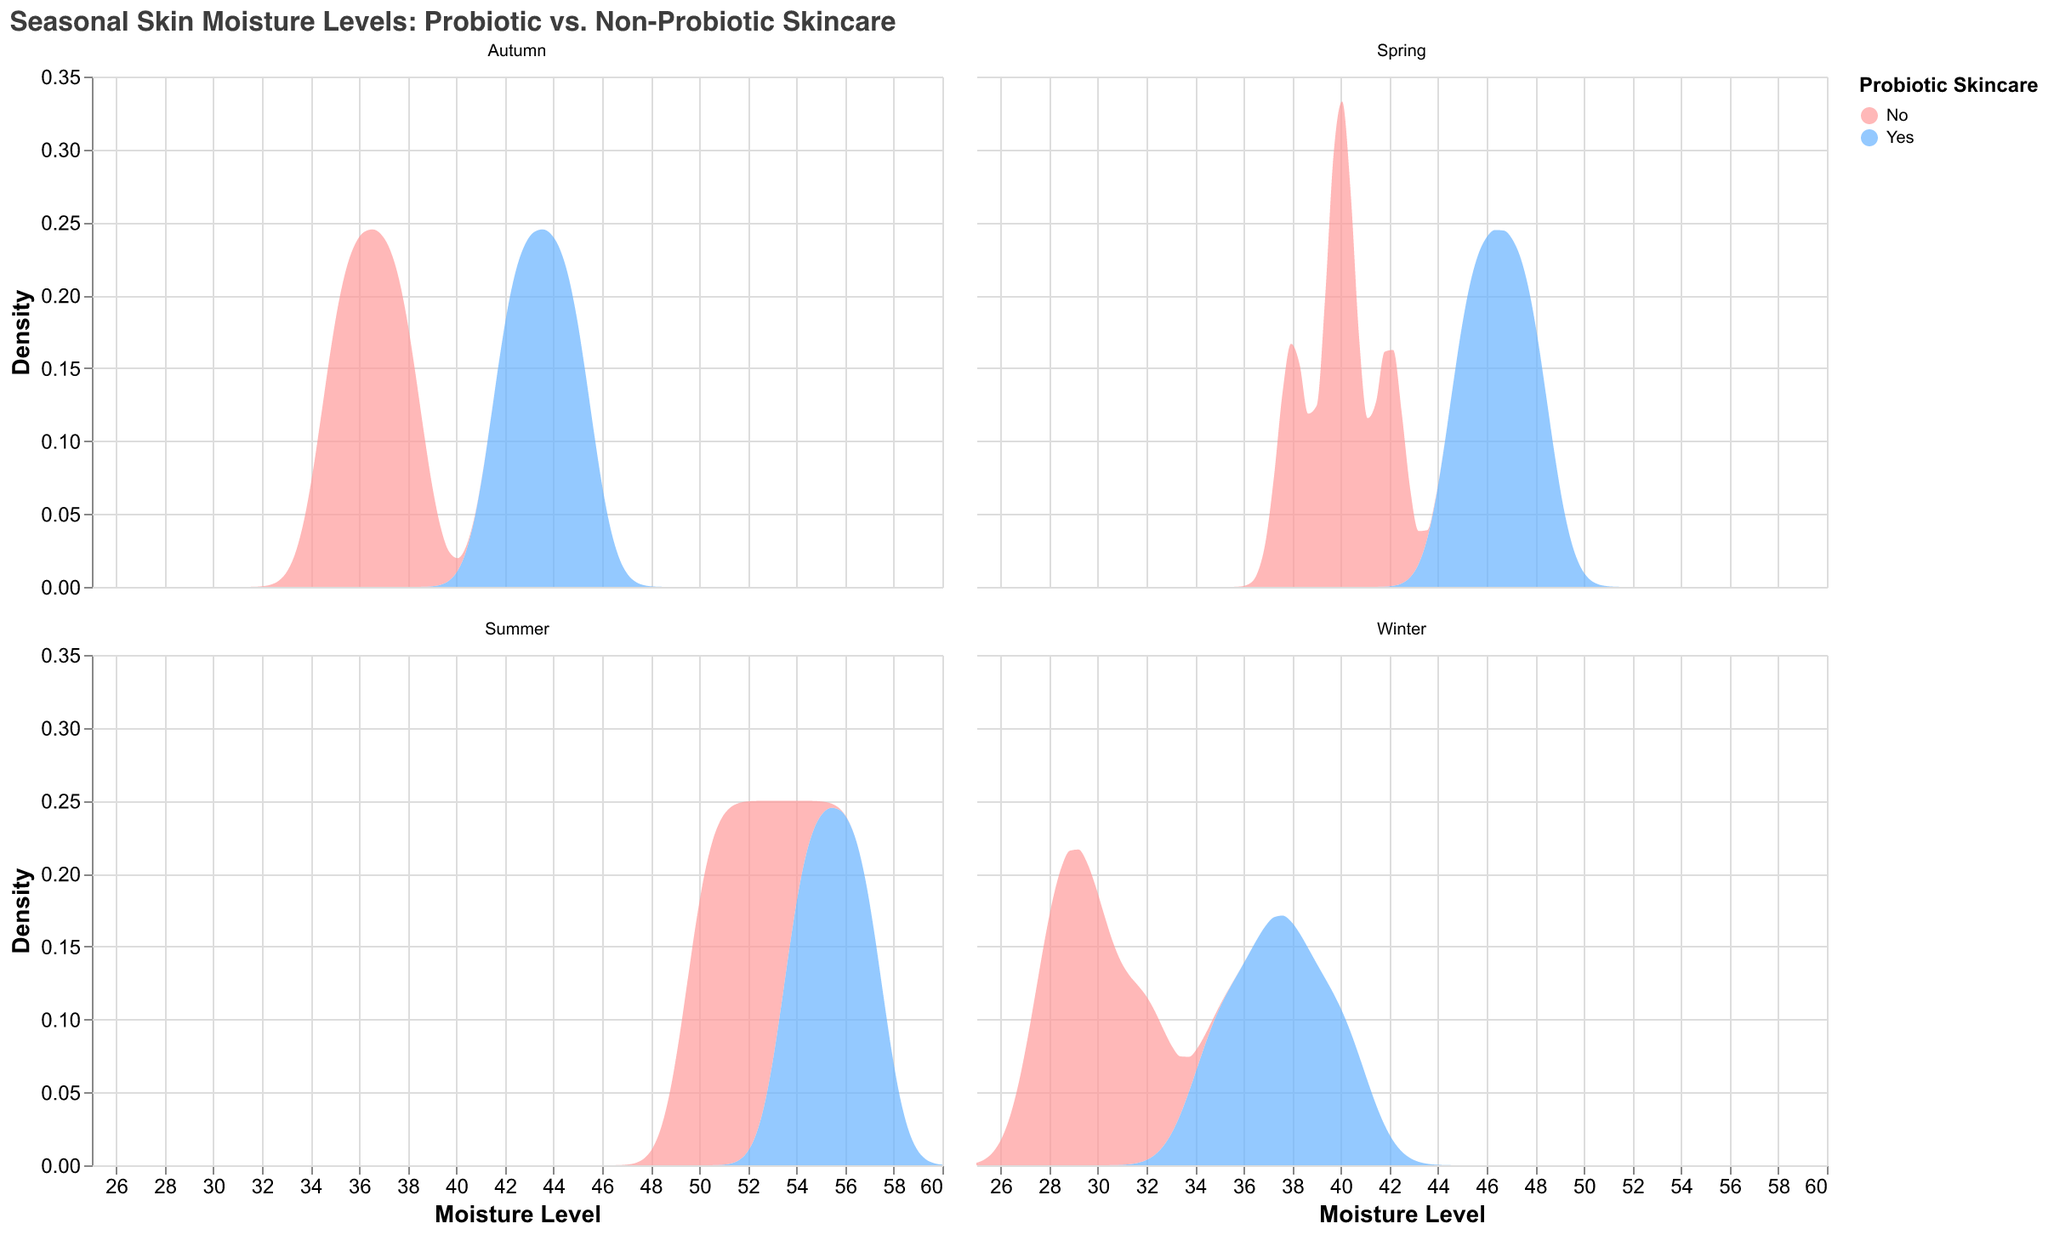What is the title of the plot? The title of the plot is displayed at the top of the figure. It reads "Seasonal Skin Moisture Levels: Probiotic vs. Non-Probiotic Skincare".
Answer: Seasonal Skin Moisture Levels: Probiotic vs. Non-Probiotic Skincare What does the x-axis represent? The x-axis at the bottom of the plot is labeled "Moisture Level" and represents the moisture level values of the skin.
Answer: Moisture Level What does the y-axis represent? The y-axis is labeled "Density" and represents the density of the moisture level data points.
Answer: Density Which color is used to represent users of probiotic skincare? The legend on the right side of the plot shows that the color blue is used to represent users of probiotic skincare.
Answer: Blue Which season shows the highest peak density for non-probiotic users? By observing the density curves in each pane, the summer season shows the highest peak density for non-probiotic users, indicated by the red curve in the summer pane.
Answer: Summer How do moisture level densities compare between probiotic and non-probiotic skincare users in winter? In winter, the density curve for users of probiotic skincare (blue) is shifted to higher moisture levels compared to non-probiotic users (red), suggesting higher moisture levels for probiotic users.
Answer: Higher for probiotic users In which season is the difference in peak moisture levels between probiotic and non-probiotic users the largest? By comparing the peaks of the density curves across seasons, summer shows the largest difference in peak moisture levels, with probiotic users having a higher peak than non-probiotic users.
Answer: Summer What is the approximate range of moisture levels for probiotic users in autumn? Observing the density curve for probiotic users in autumn (blue), the range spans from around 40 to 45 moisture levels.
Answer: 40 to 45 How does the density of moisture levels for probiotic skincare users in spring compare to autumn? The density curve for probiotic users in spring is centered around higher moisture levels (~45-48) compared to autumn (~42-45). This shows probiotic users have higher moisture levels in spring than in autumn.
Answer: Higher in spring Which season has the narrowest range of moisture levels for non-probiotic users? Analyzing the density curves for non-probiotic users, autumn has the narrowest range of moisture levels, approximately from 35 to 38.
Answer: Autumn 